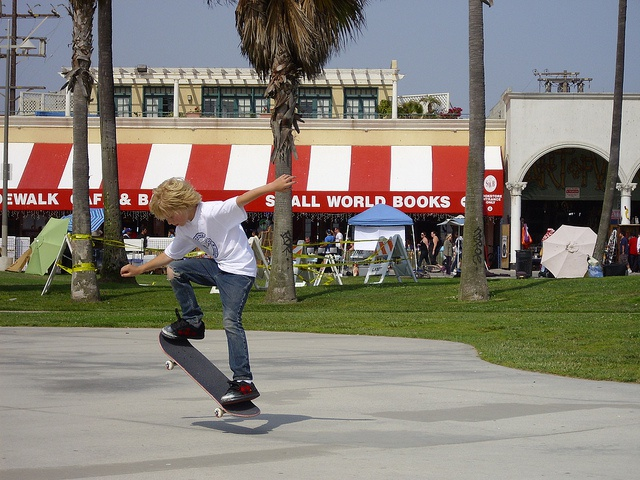Describe the objects in this image and their specific colors. I can see people in black, darkgray, gray, and lavender tones, skateboard in black, gray, and darkgray tones, umbrella in black, lightgray, and darkgray tones, umbrella in black, olive, lightgreen, and khaki tones, and people in black and gray tones in this image. 